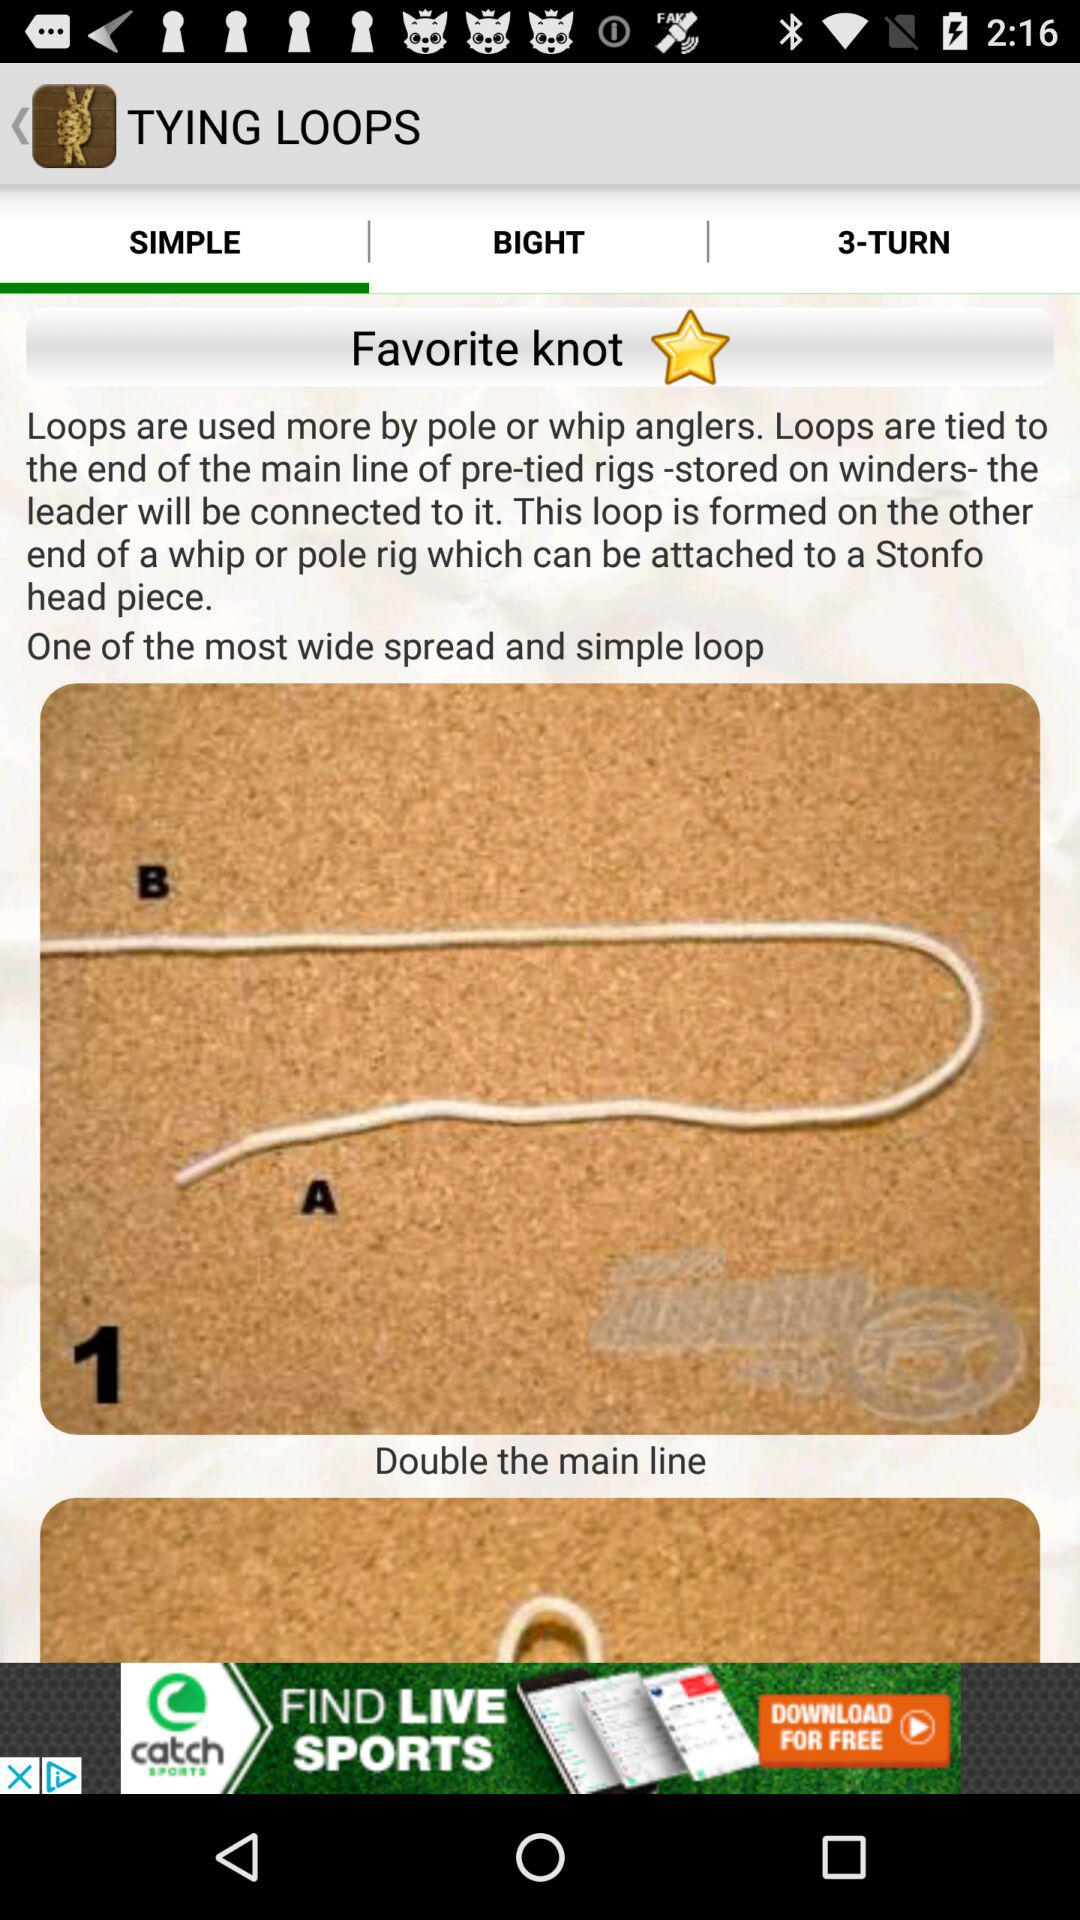What is the name of the application? The name of the application is "Ultimate Fishing Knots". 